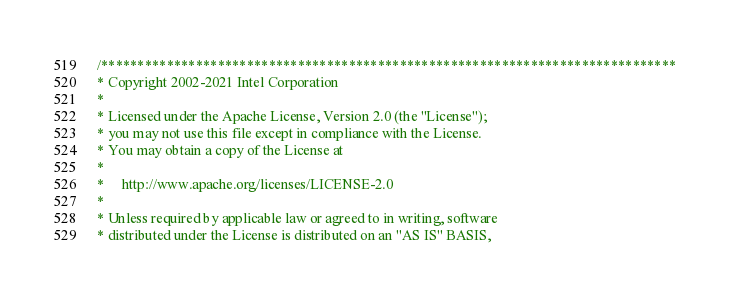<code> <loc_0><loc_0><loc_500><loc_500><_C_>/*******************************************************************************
* Copyright 2002-2021 Intel Corporation
*
* Licensed under the Apache License, Version 2.0 (the "License");
* you may not use this file except in compliance with the License.
* You may obtain a copy of the License at
*
*     http://www.apache.org/licenses/LICENSE-2.0
*
* Unless required by applicable law or agreed to in writing, software
* distributed under the License is distributed on an "AS IS" BASIS,</code> 